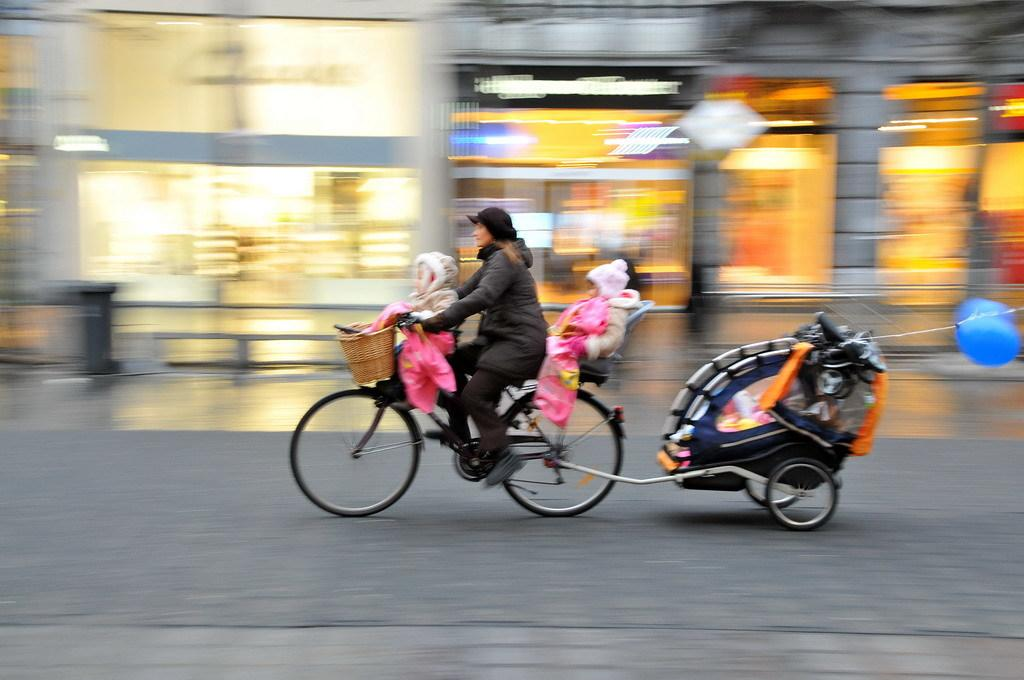Who is present in the image? There is a woman and two children in the image. What are the woman and children doing in the image? They are on a part of a group on a cycle. What else can be seen in the image? There are balloons visible in the image. What type of quiver is the woman carrying in the image? There is no quiver present in the image. Is the woman playing baseball with the children in the image? There is no baseball or any indication of a baseball game in the image. 